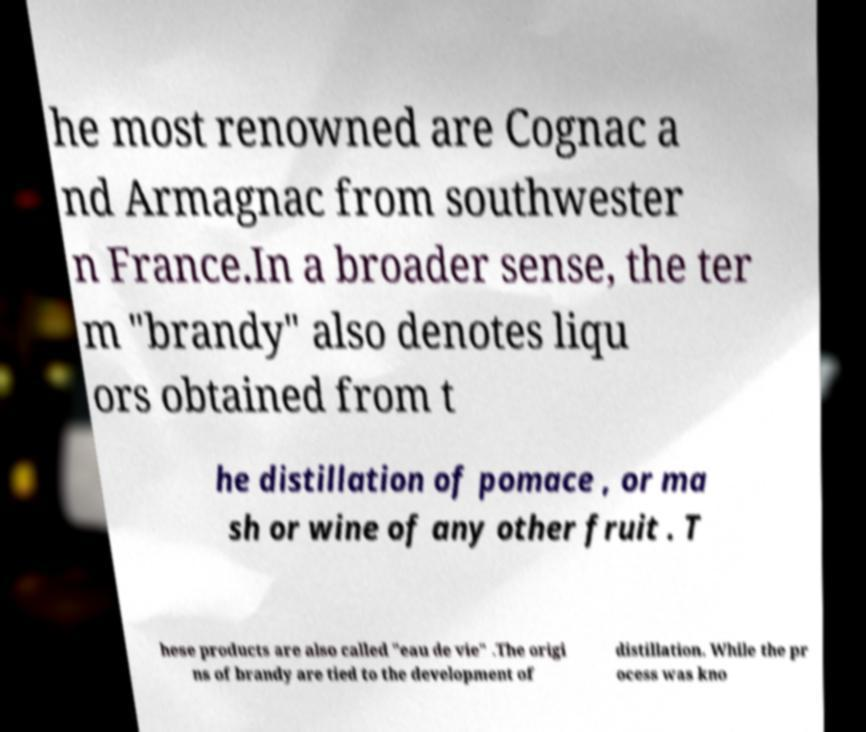Can you read and provide the text displayed in the image?This photo seems to have some interesting text. Can you extract and type it out for me? he most renowned are Cognac a nd Armagnac from southwester n France.In a broader sense, the ter m "brandy" also denotes liqu ors obtained from t he distillation of pomace , or ma sh or wine of any other fruit . T hese products are also called "eau de vie" .The origi ns of brandy are tied to the development of distillation. While the pr ocess was kno 